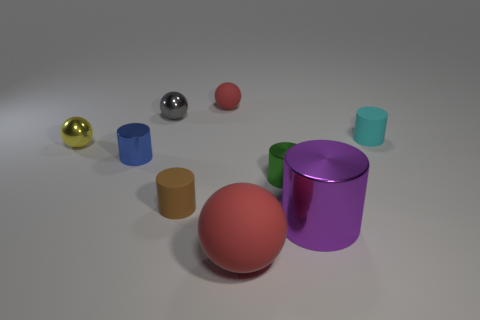Subtract 1 cylinders. How many cylinders are left? 4 Subtract all brown cylinders. How many cylinders are left? 4 Subtract all brown cylinders. How many cylinders are left? 4 Subtract all red cylinders. Subtract all red blocks. How many cylinders are left? 5 Add 1 tiny gray spheres. How many objects exist? 10 Subtract all cylinders. How many objects are left? 4 Subtract all yellow shiny objects. Subtract all matte things. How many objects are left? 4 Add 2 cyan matte cylinders. How many cyan matte cylinders are left? 3 Add 8 brown matte cylinders. How many brown matte cylinders exist? 9 Subtract 1 purple cylinders. How many objects are left? 8 